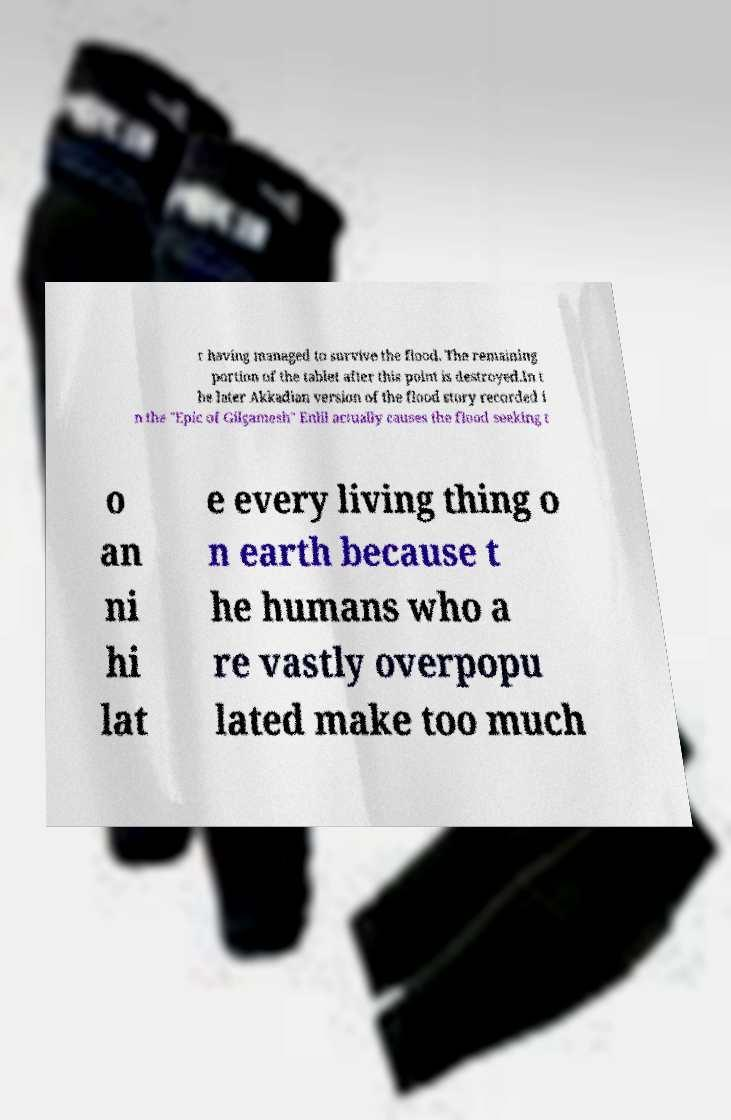What messages or text are displayed in this image? I need them in a readable, typed format. r having managed to survive the flood. The remaining portion of the tablet after this point is destroyed.In t he later Akkadian version of the flood story recorded i n the "Epic of Gilgamesh" Enlil actually causes the flood seeking t o an ni hi lat e every living thing o n earth because t he humans who a re vastly overpopu lated make too much 